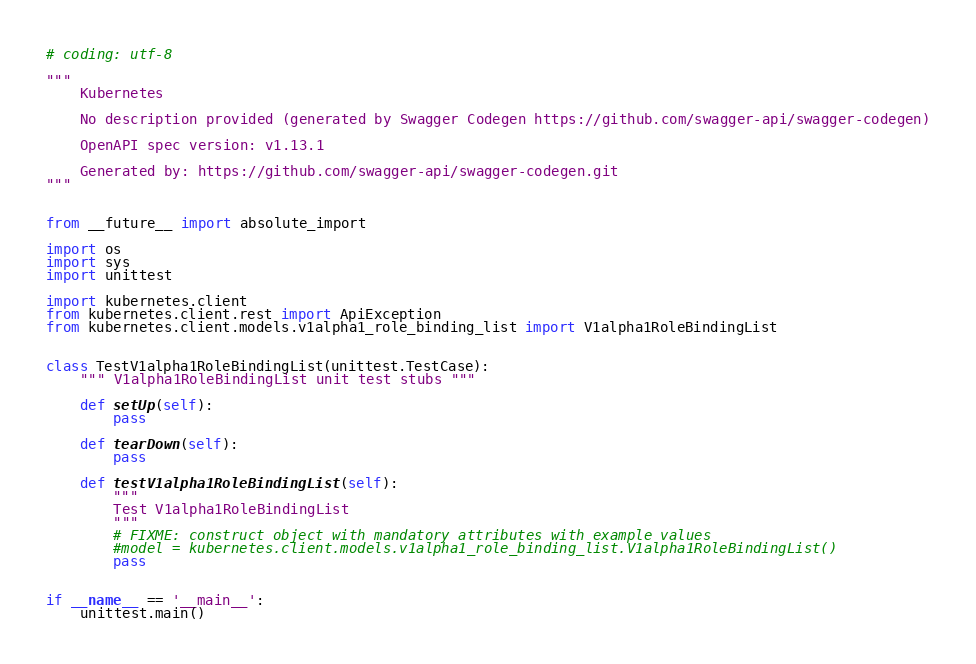<code> <loc_0><loc_0><loc_500><loc_500><_Python_># coding: utf-8

"""
    Kubernetes

    No description provided (generated by Swagger Codegen https://github.com/swagger-api/swagger-codegen)

    OpenAPI spec version: v1.13.1
    
    Generated by: https://github.com/swagger-api/swagger-codegen.git
"""


from __future__ import absolute_import

import os
import sys
import unittest

import kubernetes.client
from kubernetes.client.rest import ApiException
from kubernetes.client.models.v1alpha1_role_binding_list import V1alpha1RoleBindingList


class TestV1alpha1RoleBindingList(unittest.TestCase):
    """ V1alpha1RoleBindingList unit test stubs """

    def setUp(self):
        pass

    def tearDown(self):
        pass

    def testV1alpha1RoleBindingList(self):
        """
        Test V1alpha1RoleBindingList
        """
        # FIXME: construct object with mandatory attributes with example values
        #model = kubernetes.client.models.v1alpha1_role_binding_list.V1alpha1RoleBindingList()
        pass


if __name__ == '__main__':
    unittest.main()
</code> 